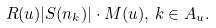<formula> <loc_0><loc_0><loc_500><loc_500>R ( u ) | S ( n _ { k } ) | \cdot M ( u ) , \, k \in A _ { u } .</formula> 